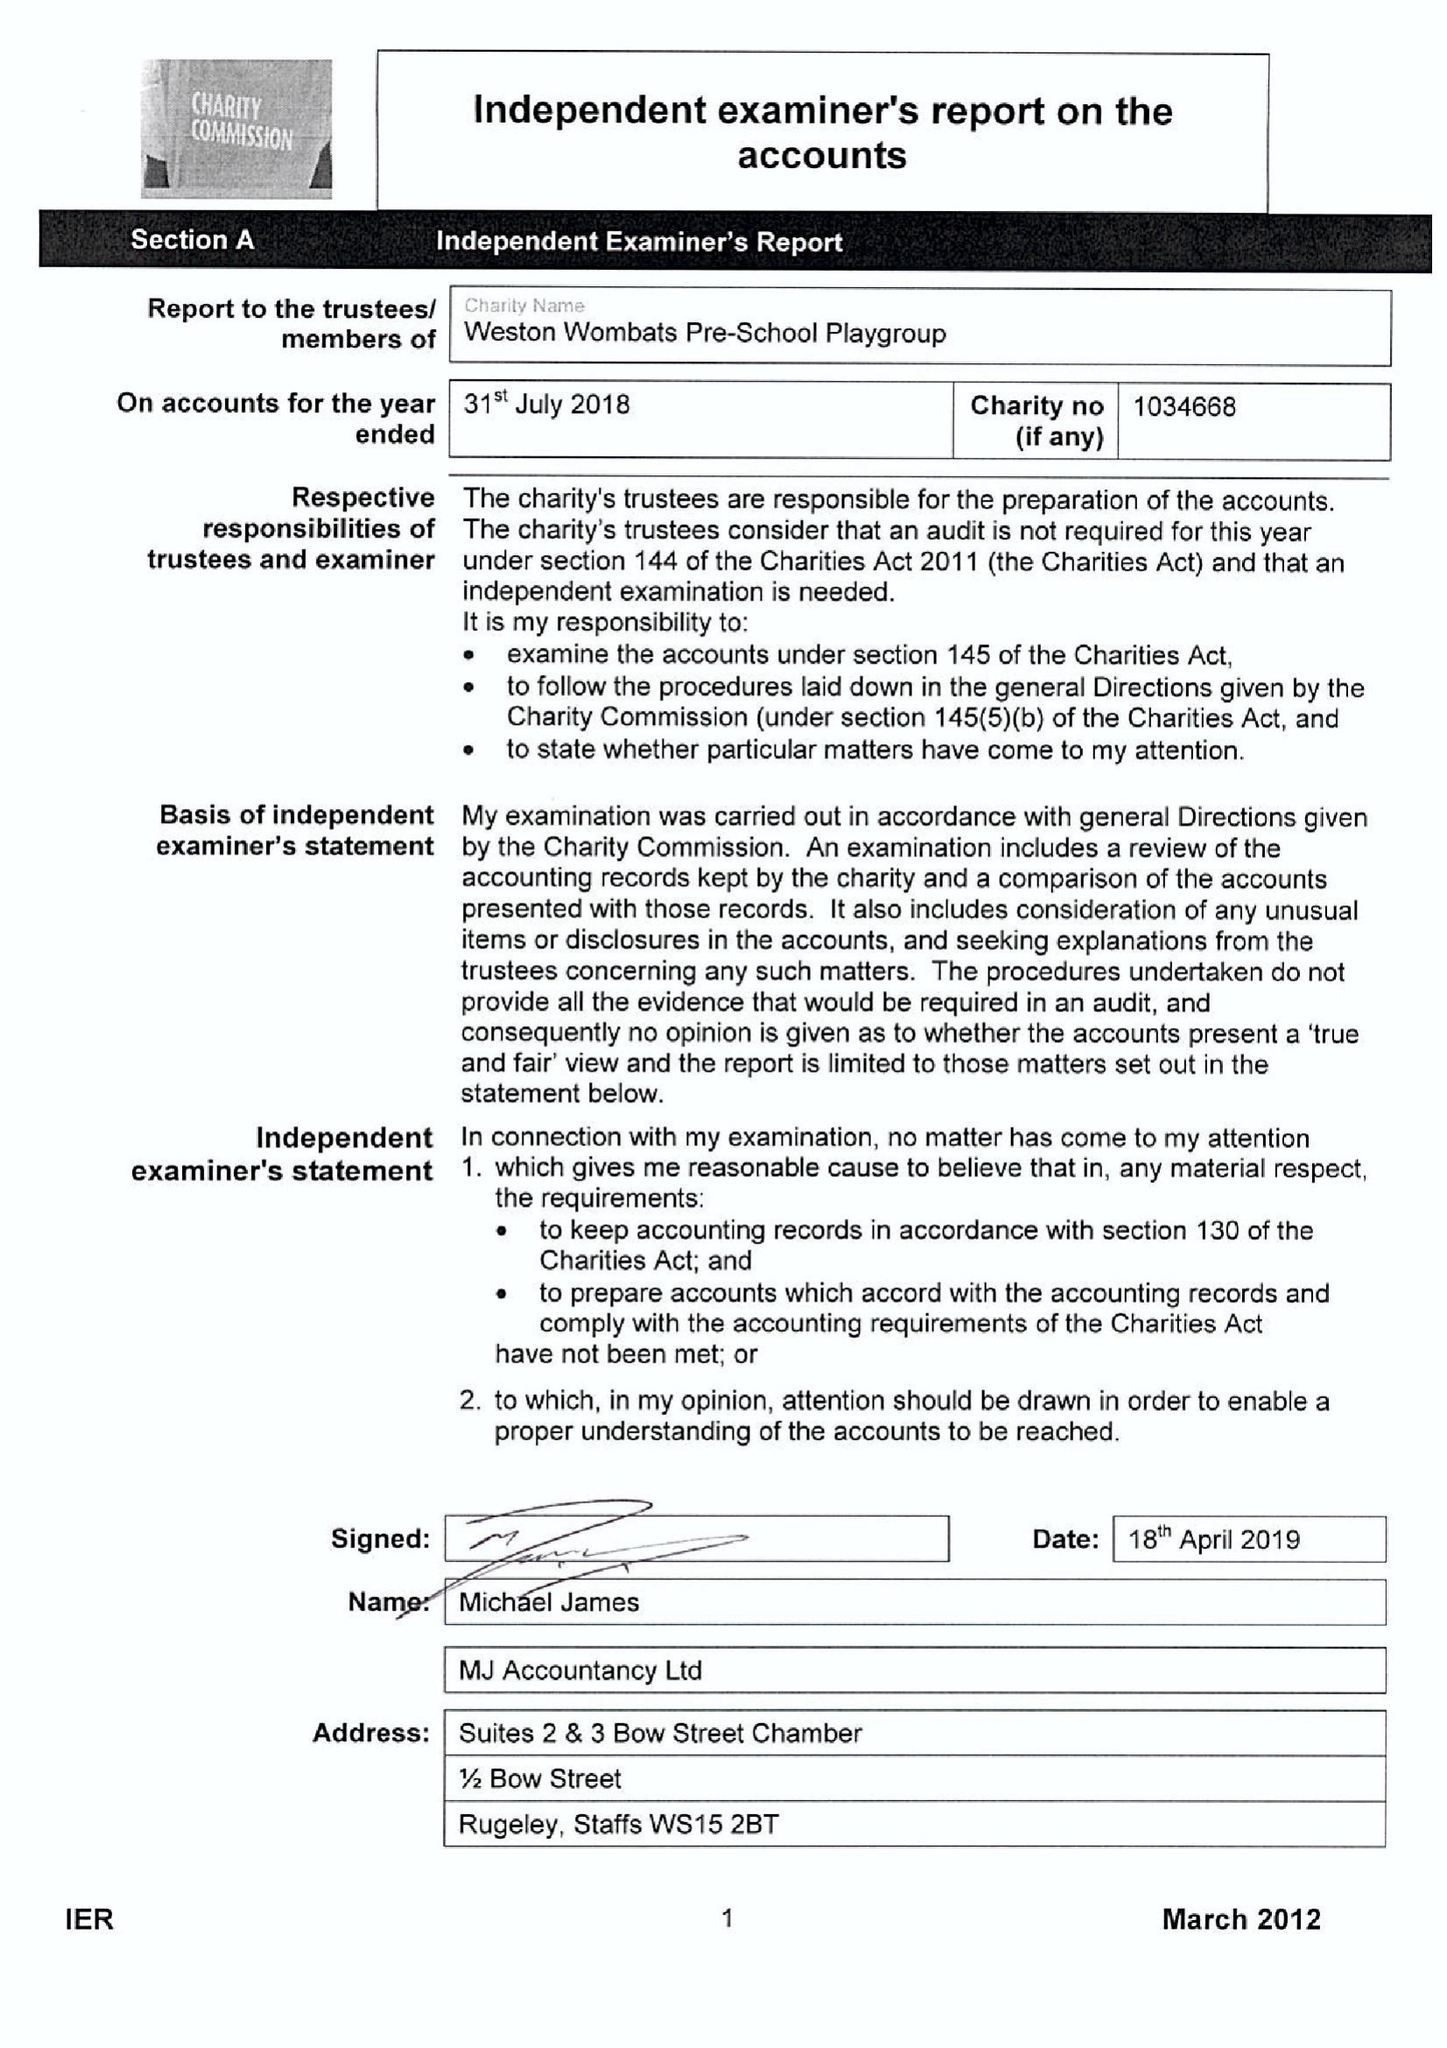What is the value for the address__postcode?
Answer the question using a single word or phrase. ST18 0BD 